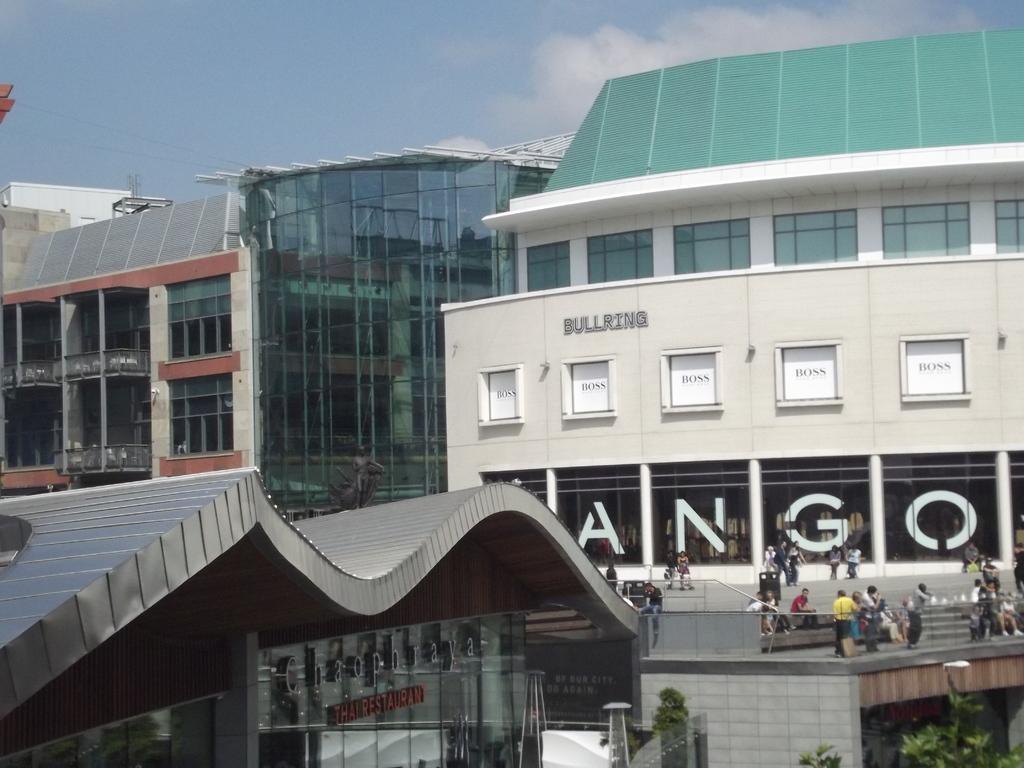Could you give a brief overview of what you see in this image? In this picture we can see buildings in the background, on the right side there are some people standing, we can see trees at the right bottom, we can see windows and glasses of these buildings, there is the sky at the top of the picture. 